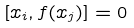Convert formula to latex. <formula><loc_0><loc_0><loc_500><loc_500>[ x _ { i } , f ( x _ { j } ) ] = 0</formula> 